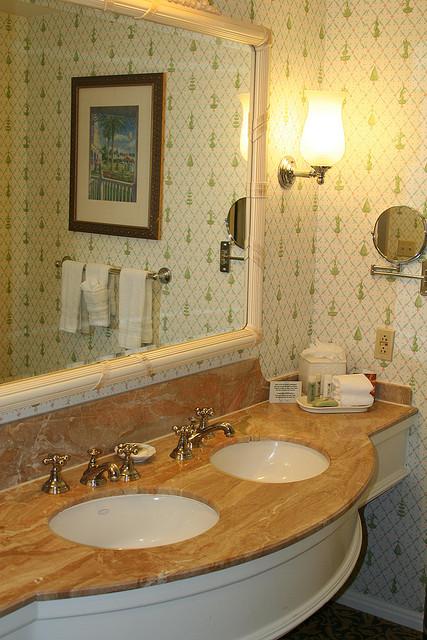What room is this?
Quick response, please. Bathroom. How many faucets?
Answer briefly. 2. What color are the towel?
Be succinct. White. 